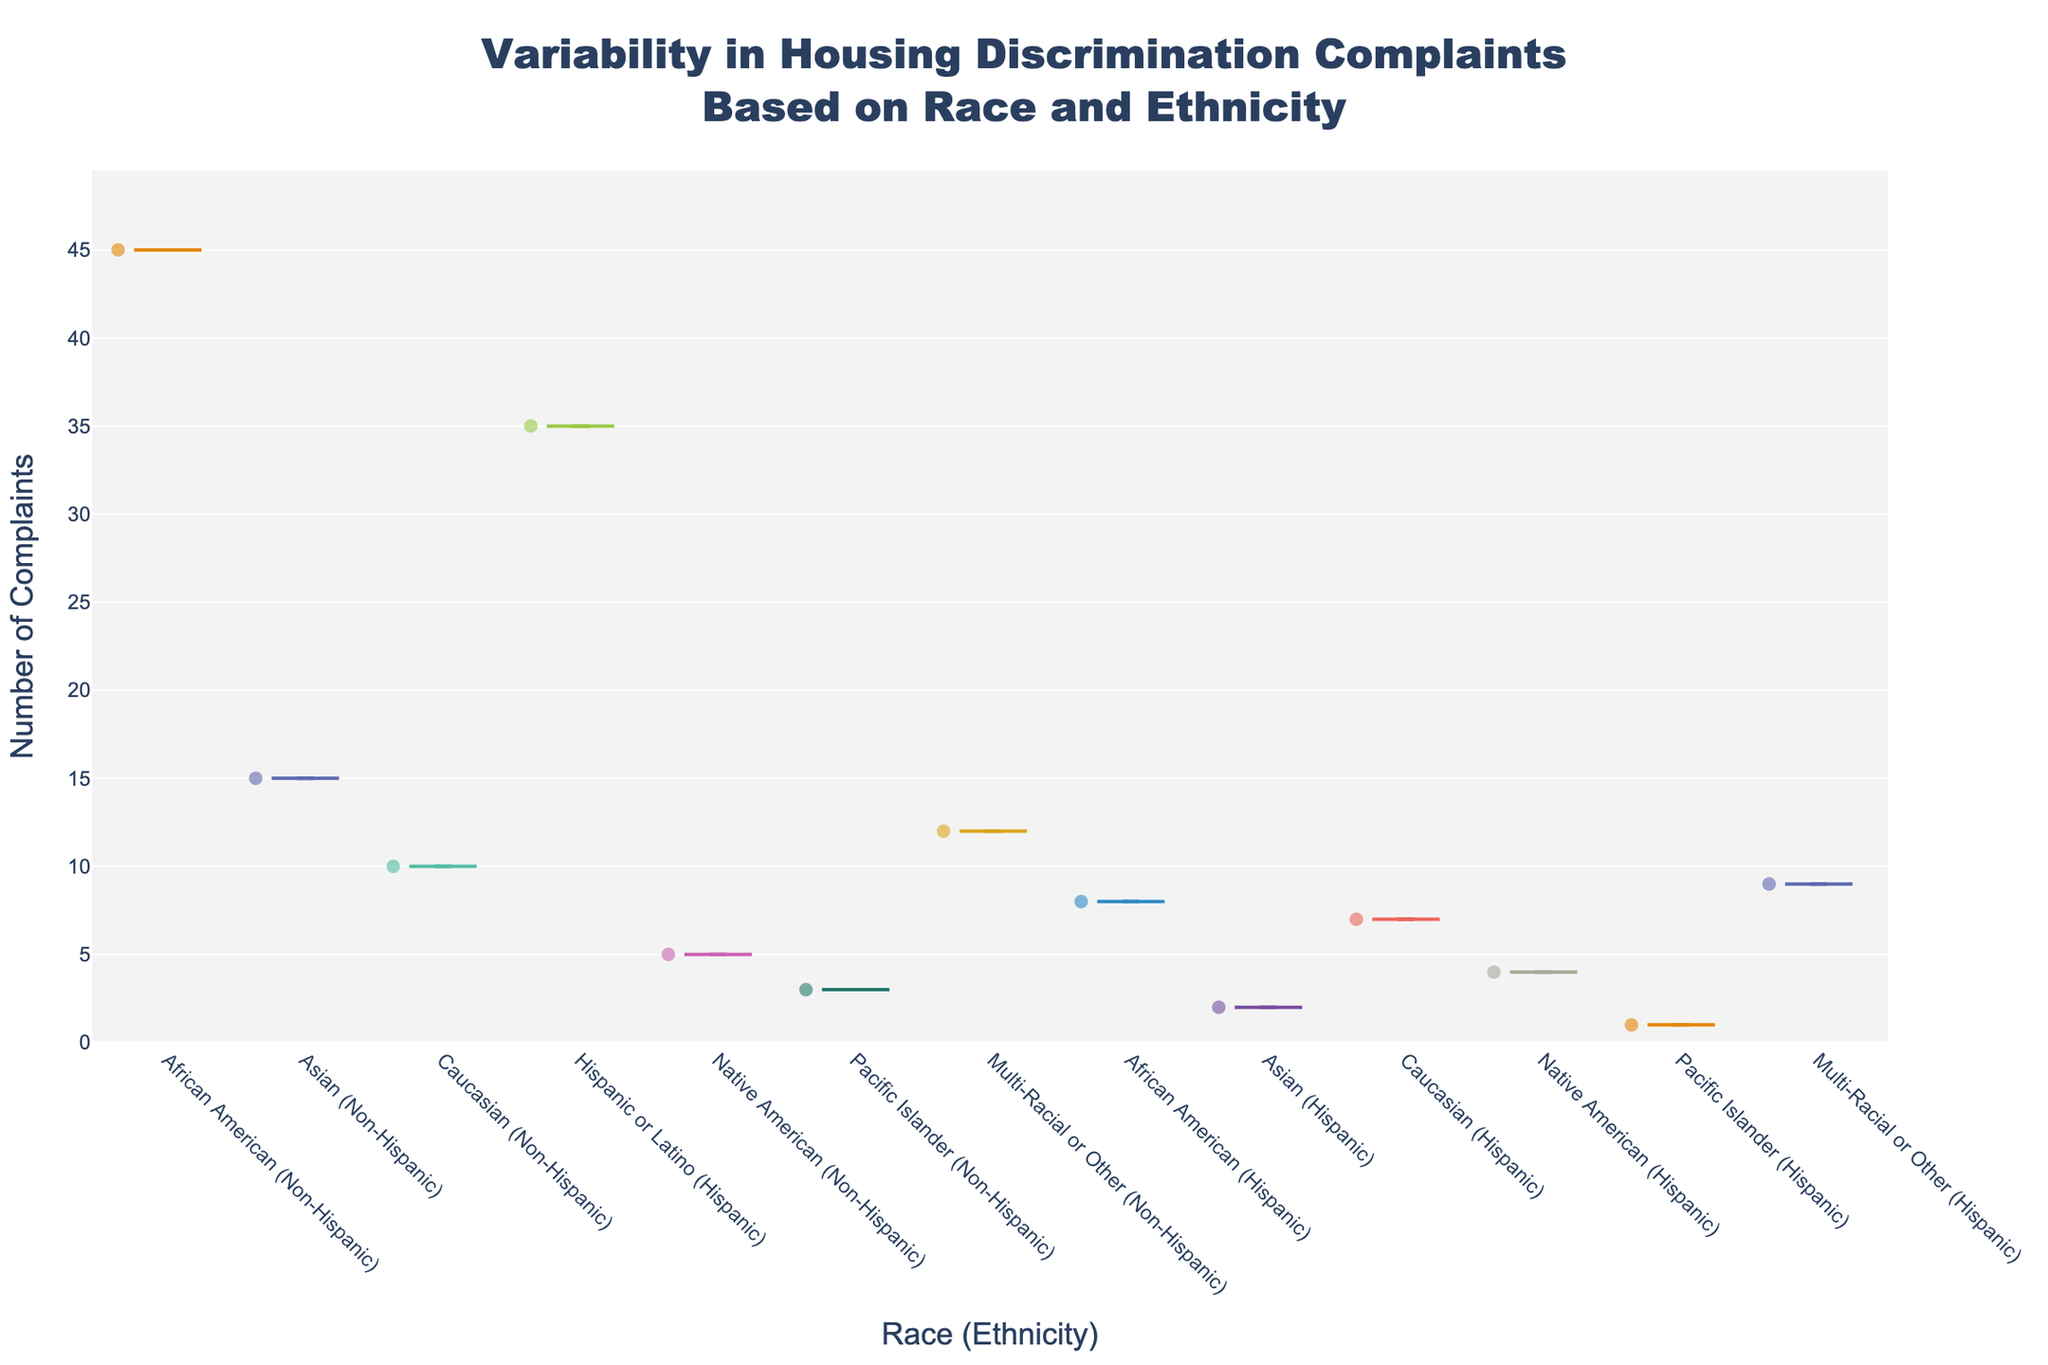What is the title of the chart? The title can be found at the top of the chart. In this case, it is "Variability in Housing Discrimination Complaints Based on Race and Ethnicity".
Answer: Variability in Housing Discrimination Complaints Based on Race and Ethnicity What is the y-axis representing? The y-axis represents the number of complaints. This is evident from the y-axis title "Number of Complaints".
Answer: Number of Complaints Which group has the highest number of complaints? By examining the y-axis values and the spread of data points, it is clear that "African American (Non-Hispanic)" has the highest complaints, peaking at 45.
Answer: African American (Non-Hispanic) What is the median number of complaints for "Hispanic or Latino (Hispanic)"? Look at the middle value of the box in the violin plot for "Hispanic or Latino (Hispanic)". The median is indicated by the box's central line.
Answer: 35 Which ethnic groups have both "Hispanic" and "Non-Hispanic" categories listed? Scan through the x-axis labels to identify which groups appear with both "Hispanic" and "Non-Hispanic" annotations.
Answer: African American, Asian, Caucasian, Native American, Pacific Islander, Multi-Racial or Other Compare the number of complaints between "African American (Non-Hispanic)" and "African American (Hispanic)" groups. Which has more complaints? Compare the peaks of both violin plots. "African American (Non-Hispanic)" has a peak at 45, and "African American (Hispanic)" has a peak at 8.
Answer: African American (Non-Hispanic) Which group has the least number of complaints, and how many complaints are there? Scan through all the violin plots to find the lowest peak. "Pacific Islander (Hispanic)" has the least number with 1 complaint.
Answer: Pacific Islander (Hispanic), 1 How does the range of complaints for "Multi-Racial or Other (Non-Hispanic)" compare to "Multi-Racial or Other (Hispanic)"? Examine the y-axis spans of both violins. "Multi-Racial or Other (Non-Hispanic)" ranges up to 12, while "Multi-Racial or Other (Hispanic)" ranges up to 9.
Answer: Non-Hispanic has a wider range What is the average number of complaints for "Native American" groups across both ethnicities? Calculate the average by summing the complaints in "Native American (Non-Hispanic)" and "Native American (Hispanic)", then divide by 2: (5 + 4)/2 = 4.5.
Answer: 4.5 Which group shows the highest variability in complaints? Look for the violin plot with the widest spread of data points, indicating higher variability. "African American (Non-Hispanic)" shows the highest spread.
Answer: African American (Non-Hispanic) 